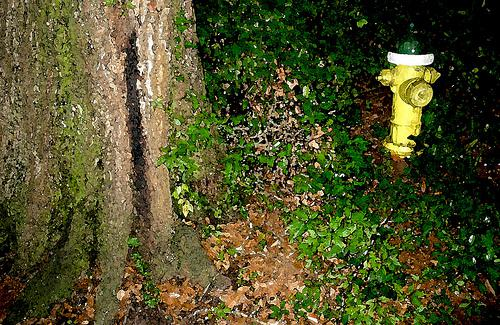Question: what is growing on the tree?
Choices:
A. Apples.
B. Ivy.
C. Pears.
D. Peaches.
Answer with the letter. Answer: B Question: what is the fire hydrant next to?
Choices:
A. The road.
B. A tree.
C. A School.
D. A mall.
Answer with the letter. Answer: B Question: what time of day is this?
Choices:
A. Morning.
B. Lunch time.
C. Midnight.
D. Evening.
Answer with the letter. Answer: D Question: what color is the ivy?
Choices:
A. Red.
B. Green.
C. Brown.
D. Black.
Answer with the letter. Answer: B 